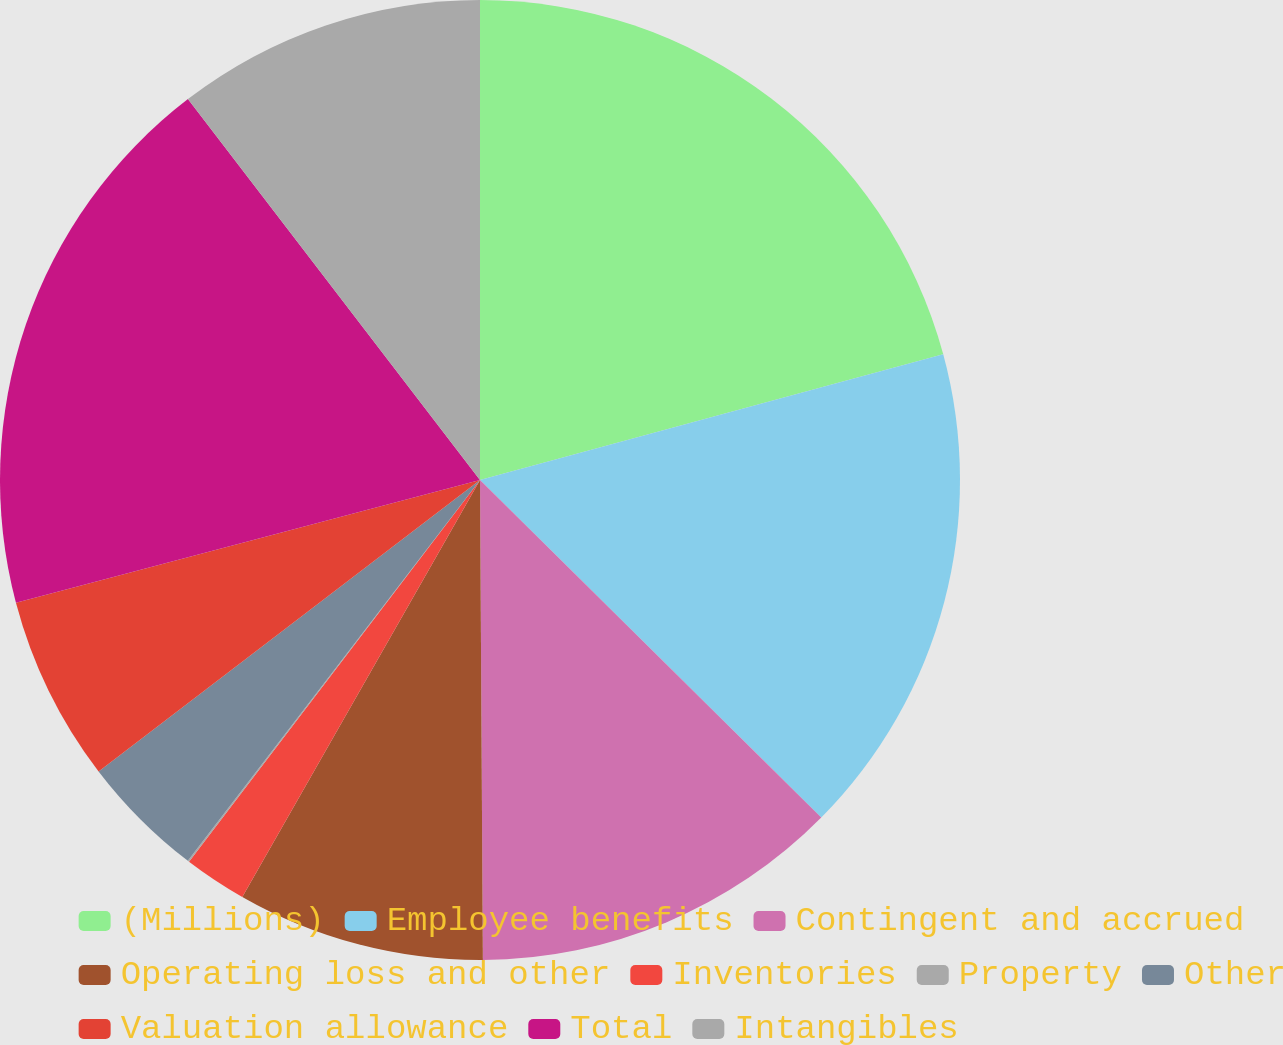<chart> <loc_0><loc_0><loc_500><loc_500><pie_chart><fcel>(Millions)<fcel>Employee benefits<fcel>Contingent and accrued<fcel>Operating loss and other<fcel>Inventories<fcel>Property<fcel>Other<fcel>Valuation allowance<fcel>Total<fcel>Intangibles<nl><fcel>20.78%<fcel>16.63%<fcel>12.49%<fcel>8.34%<fcel>2.12%<fcel>0.05%<fcel>4.2%<fcel>6.27%<fcel>18.7%<fcel>10.41%<nl></chart> 